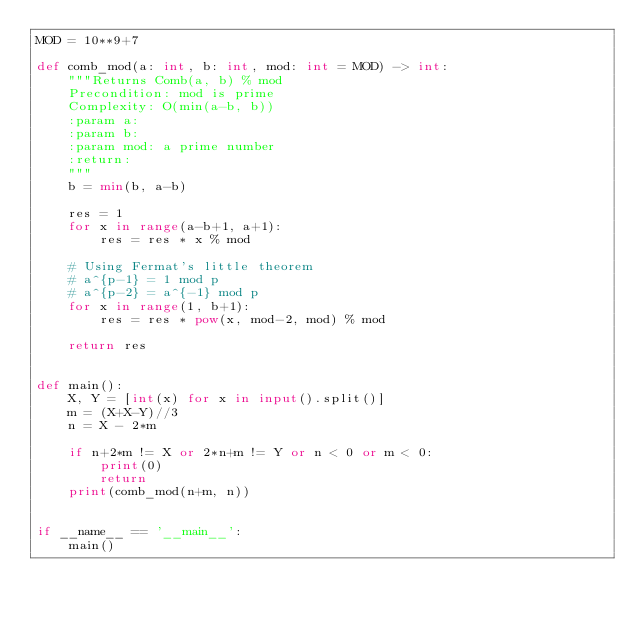<code> <loc_0><loc_0><loc_500><loc_500><_Python_>MOD = 10**9+7

def comb_mod(a: int, b: int, mod: int = MOD) -> int:
    """Returns Comb(a, b) % mod
    Precondition: mod is prime
    Complexity: O(min(a-b, b))
    :param a:
    :param b:
    :param mod: a prime number
    :return:
    """
    b = min(b, a-b)

    res = 1
    for x in range(a-b+1, a+1):
        res = res * x % mod

    # Using Fermat's little theorem
    # a^{p-1} = 1 mod p
    # a^{p-2} = a^{-1} mod p
    for x in range(1, b+1):
        res = res * pow(x, mod-2, mod) % mod

    return res


def main():
    X, Y = [int(x) for x in input().split()]
    m = (X+X-Y)//3
    n = X - 2*m

    if n+2*m != X or 2*n+m != Y or n < 0 or m < 0:
        print(0)
        return
    print(comb_mod(n+m, n))


if __name__ == '__main__':
    main()</code> 